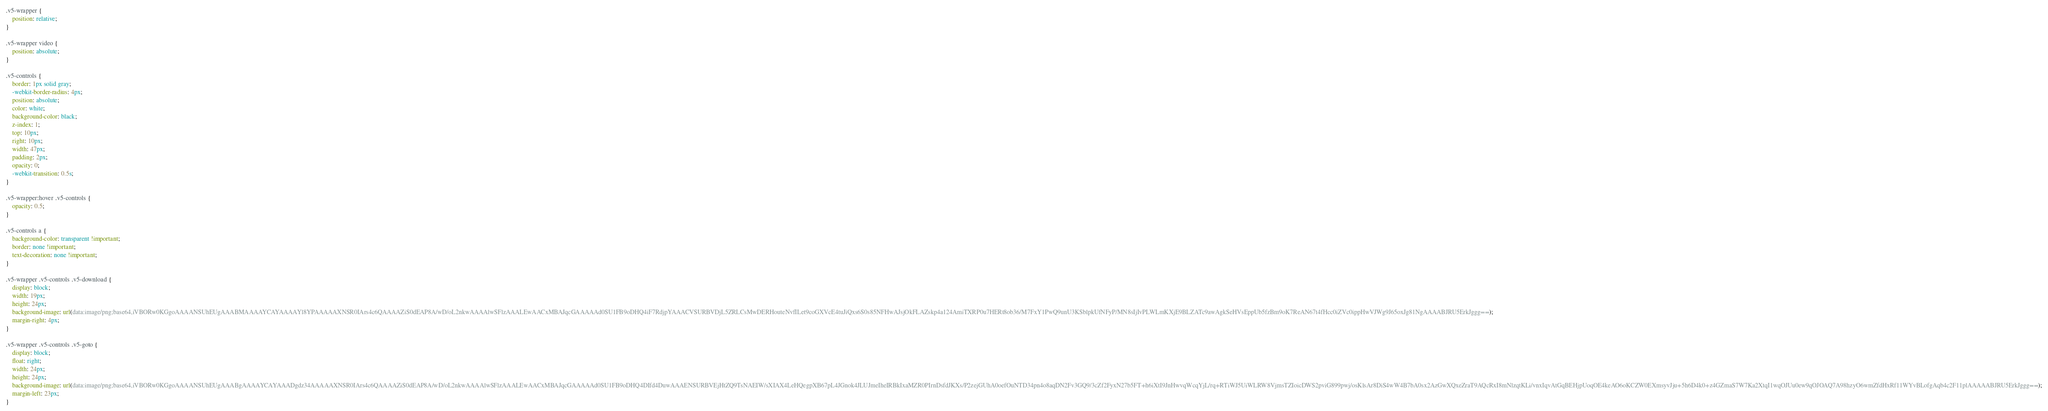Convert code to text. <code><loc_0><loc_0><loc_500><loc_500><_CSS_>.v5-wrapper {
    position: relative;
}

.v5-wrapper video {
    position: absolute;
}

.v5-controls {
    border: 1px solid gray;
    -webkit-border-radius: 4px;
    position: absolute;
    color: white;
    background-color: black;
    z-index: 1;
    top: 10px;
    right: 10px;
    width: 47px;
    padding: 2px;
    opacity: 0;
    -webkit-transition: 0.5s;
}

.v5-wrapper:hover .v5-controls {
    opacity: 0.5;
}

.v5-controls a {
    background-color: transparent !important;
    border: none !important;
    text-decoration: none !important;
}

.v5-wrapper .v5-controls .v5-download {
    display: block;
    width: 19px;
    height: 24px;
    background-image: url(data:image/png;base64,iVBORw0KGgoAAAANSUhEUgAAABMAAAAYCAYAAAAYl8YPAAAAAXNSR0IArs4c6QAAAAZiS0dEAP8A/wD/oL2nkwAAAAlwSFlzAAALEwAACxMBAJqcGAAAAAd0SU1FB9oDHQ4iF7RdjpYAAACVSURBVDjL5ZRLCsMwDERHouteNvfILet9coGXVcE4tuJiQxs6S0s85NFHwAJsjOkFLAZskp4a124AmiTXRP0u7HERt8ob36/M7FxY1PwQ9unU3KSblpkUfNFyP/MN8sIjIvPLWLmKXjE9BLZATc9awAgkSeHVsEppUb5fzBm9oK7ReAN67t4fHcc0iZVc0ippHwVJWg9J65oxJg81NgAAAABJRU5ErkJggg==);
    margin-right: 4px;
}

.v5-wrapper .v5-controls .v5-goto {
    display: block;
    float: right;
    width: 24px;
    height: 24px;
    background-image: url(data:image/png;base64,iVBORw0KGgoAAAANSUhEUgAAABgAAAAYCAYAAADgdz34AAAAAXNSR0IArs4c6QAAAAZiS0dEAP8A/wD/oL2nkwAAAAlwSFlzAAALEwAACxMBAJqcGAAAAAd0SU1FB9oDHQ4DIfd4DuwAAAENSURBVEjHtZQ9TsNAEIW/sXIAX4LeHQegpXB67pL4JGnok4JLUJmeIheIRBkIxaMZR0PIrnDsfdJKXs/P2zejGUhA0oefOuNTD34pn4o8aqDN2Fv3GQ9/3cZf2FyxN27b5FT+h6iXtI9JnHwvqWcqYjL/rq+RTiWJ5UiWLRW8VjmsTZIoicDWS2pviG899pwj/osKlsAr8DiS4wW4B7bA0sx2AzGwXQxeZraT9AQcRxI8mNlzqtKLi/vnxIqvAtGqBEHjpUoqOE4keAO6oKCZW0EXmsyvJju+5h6D4k0+z4GZmaS7W7Ka2XtqI1wqOJUu0ew9qOJOAQ7A98hzyO6wmZfdHxRf11WYvBLofgAqb4c2F11plAAAAABJRU5ErkJggg==);
    margin-left: 23px;
}
</code> 